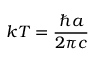<formula> <loc_0><loc_0><loc_500><loc_500>k T = { \frac { \hbar { a } } { 2 \pi c } }</formula> 